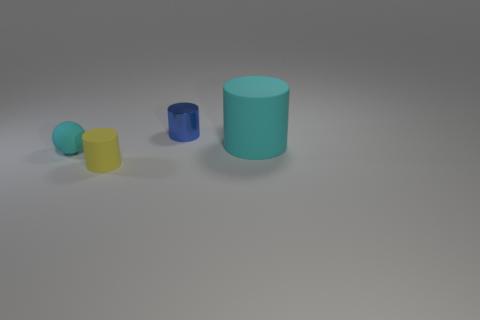What number of matte things are yellow cylinders or small balls?
Keep it short and to the point. 2. The yellow rubber thing that is the same shape as the blue object is what size?
Provide a short and direct response. Small. Are there any other things that have the same size as the blue shiny thing?
Your response must be concise. Yes. Do the cyan cylinder and the rubber cylinder that is in front of the small sphere have the same size?
Your answer should be compact. No. There is a thing that is to the left of the yellow cylinder; what is its shape?
Keep it short and to the point. Sphere. There is a small object to the left of the matte cylinder left of the cyan matte cylinder; what is its color?
Your answer should be very brief. Cyan. What is the color of the small shiny thing that is the same shape as the big cyan thing?
Provide a succinct answer. Blue. What number of balls are the same color as the large cylinder?
Keep it short and to the point. 1. Do the small matte sphere and the cylinder that is behind the large rubber cylinder have the same color?
Your answer should be compact. No. There is a tiny object that is right of the matte ball and in front of the tiny blue cylinder; what is its shape?
Provide a short and direct response. Cylinder. 